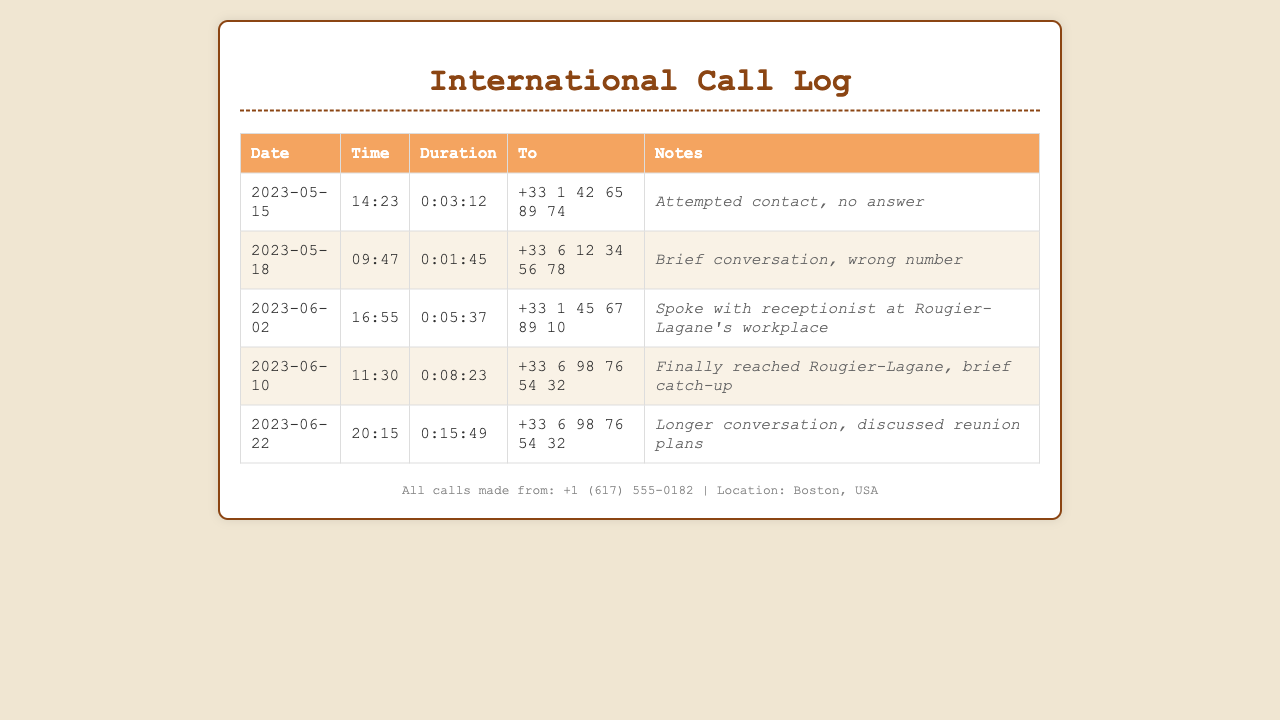What date was the call made to Rougier-Lagane? The call to Rougier-Lagane was made on June 10, 2023.
Answer: June 10, 2023 How long was the conversation with Rougier-Lagane on June 22? The conversation with Rougier-Lagane on June 22 lasted for 15 minutes and 49 seconds.
Answer: 0:15:49 What was said during the call on June 2? On June 2, the caller spoke with a receptionist at Rougier-Lagane's workplace.
Answer: Receptionist How many unsuccessful call attempts were made before contacting Rougier-Lagane? There were two unsuccessful call attempts before contacting Rougier-Lagane.
Answer: 2 What is the phone number that was finally reached on June 10? The phone number reached on June 10 was +33 6 98 76 54 32.
Answer: +33 6 98 76 54 32 What was the duration of the call to the wrong number on May 18? The duration of the call to the wrong number on May 18 was 1 minute and 45 seconds.
Answer: 0:01:45 What is the total number of calls recorded in the log? The total number of calls recorded in the log is 5.
Answer: 5 Who picked up the call on June 2? The call on June 2 was picked up by a receptionist.
Answer: Receptionist 